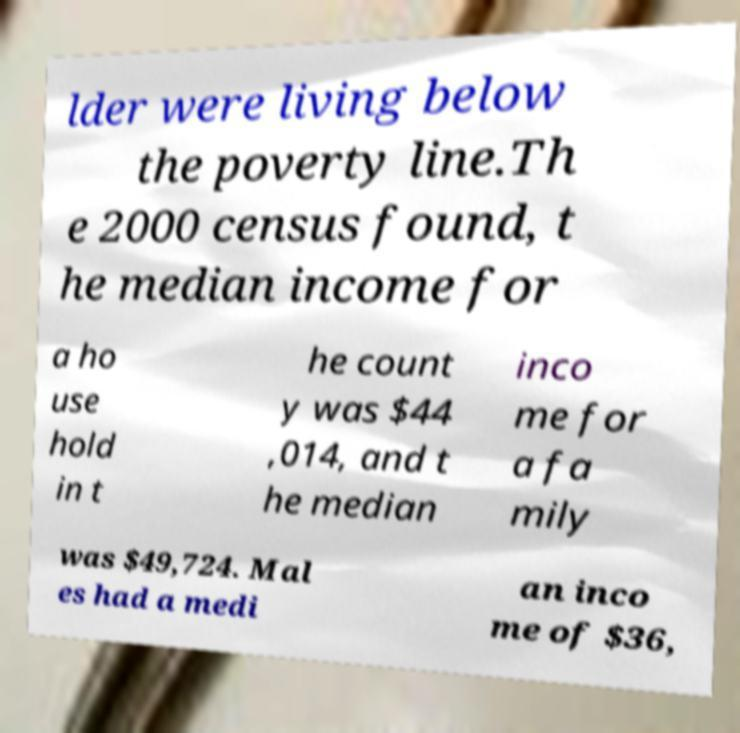Can you read and provide the text displayed in the image?This photo seems to have some interesting text. Can you extract and type it out for me? lder were living below the poverty line.Th e 2000 census found, t he median income for a ho use hold in t he count y was $44 ,014, and t he median inco me for a fa mily was $49,724. Mal es had a medi an inco me of $36, 